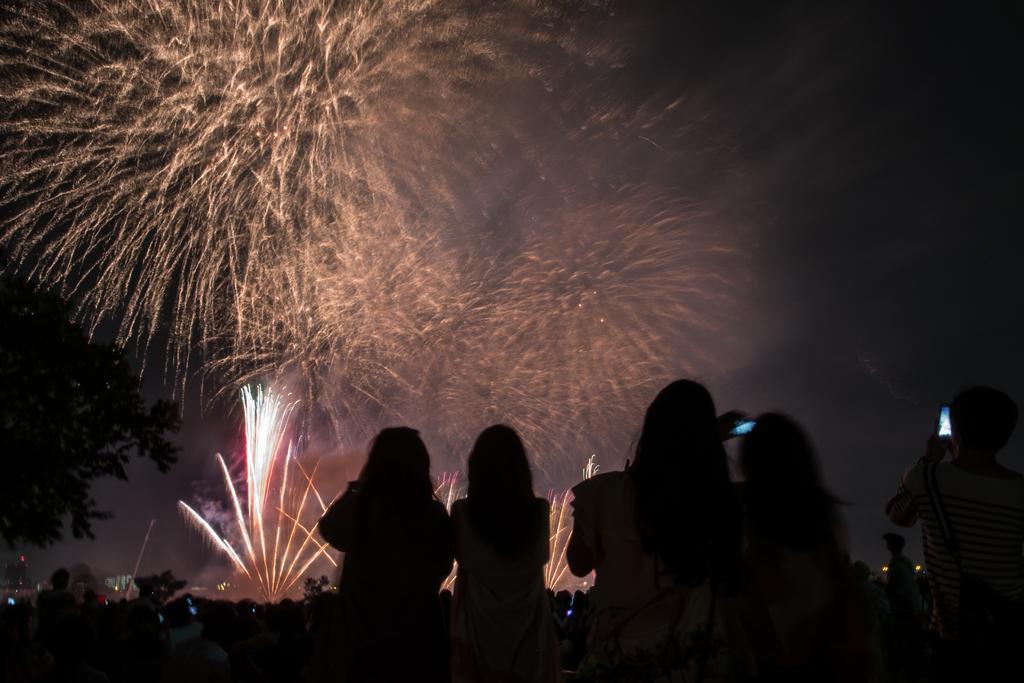Describe this image in one or two sentences. In the picture we can see few women are sitting and watching the fire crackers show. 